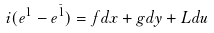<formula> <loc_0><loc_0><loc_500><loc_500>i ( e ^ { 1 } - e ^ { \bar { 1 } } ) = f d x + g d y + L d u</formula> 